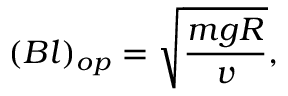Convert formula to latex. <formula><loc_0><loc_0><loc_500><loc_500>( B l ) _ { o p } = \sqrt { \frac { m g R } { v } } ,</formula> 